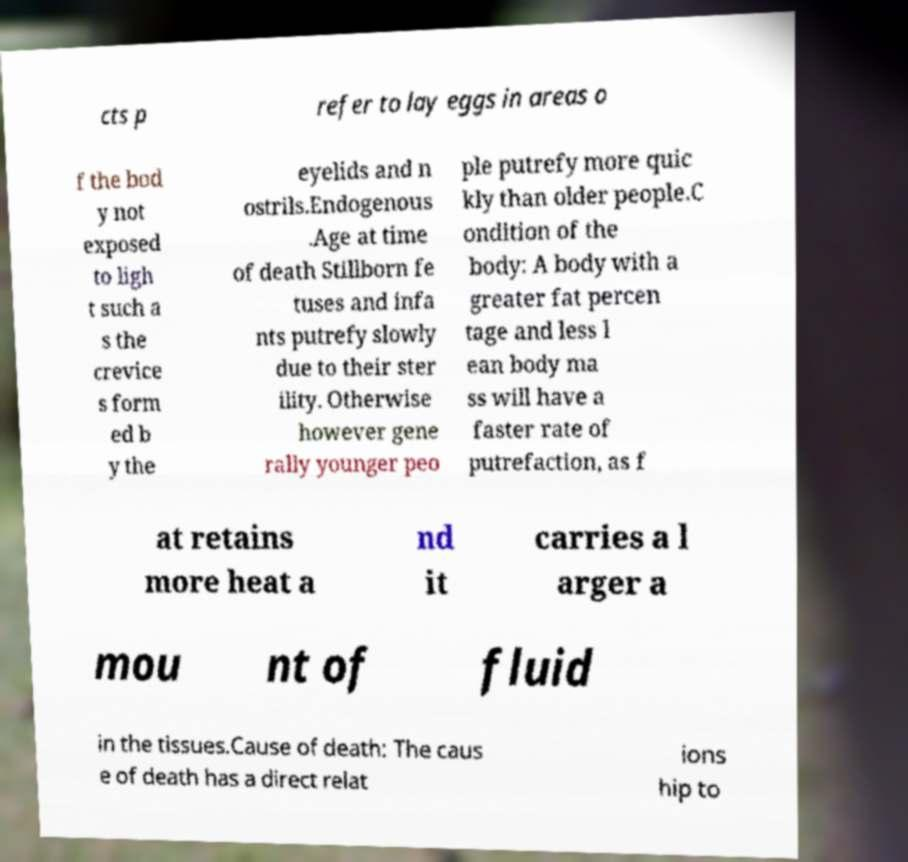For documentation purposes, I need the text within this image transcribed. Could you provide that? cts p refer to lay eggs in areas o f the bod y not exposed to ligh t such a s the crevice s form ed b y the eyelids and n ostrils.Endogenous .Age at time of death Stillborn fe tuses and infa nts putrefy slowly due to their ster ility. Otherwise however gene rally younger peo ple putrefy more quic kly than older people.C ondition of the body: A body with a greater fat percen tage and less l ean body ma ss will have a faster rate of putrefaction, as f at retains more heat a nd it carries a l arger a mou nt of fluid in the tissues.Cause of death: The caus e of death has a direct relat ions hip to 